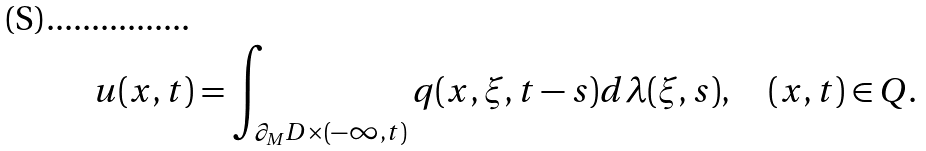<formula> <loc_0><loc_0><loc_500><loc_500>u ( x , t ) = \int _ { \partial _ { M } D \times ( - \infty , t ) } q ( x , \xi , t - s ) d \lambda ( \xi , s ) , \quad ( x , t ) \in Q .</formula> 